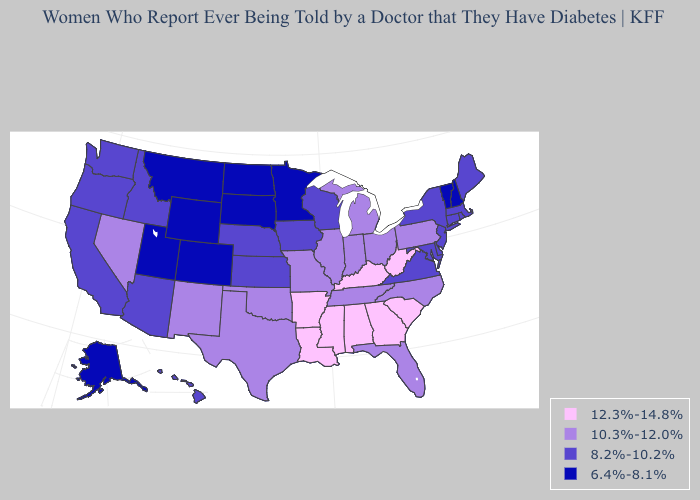What is the value of North Dakota?
Give a very brief answer. 6.4%-8.1%. Which states have the highest value in the USA?
Give a very brief answer. Alabama, Arkansas, Georgia, Kentucky, Louisiana, Mississippi, South Carolina, West Virginia. Which states have the lowest value in the South?
Short answer required. Delaware, Maryland, Virginia. Which states have the highest value in the USA?
Write a very short answer. Alabama, Arkansas, Georgia, Kentucky, Louisiana, Mississippi, South Carolina, West Virginia. What is the lowest value in states that border Maryland?
Keep it brief. 8.2%-10.2%. Name the states that have a value in the range 8.2%-10.2%?
Answer briefly. Arizona, California, Connecticut, Delaware, Hawaii, Idaho, Iowa, Kansas, Maine, Maryland, Massachusetts, Nebraska, New Jersey, New York, Oregon, Rhode Island, Virginia, Washington, Wisconsin. What is the lowest value in the USA?
Concise answer only. 6.4%-8.1%. Name the states that have a value in the range 10.3%-12.0%?
Keep it brief. Florida, Illinois, Indiana, Michigan, Missouri, Nevada, New Mexico, North Carolina, Ohio, Oklahoma, Pennsylvania, Tennessee, Texas. Among the states that border New Jersey , which have the highest value?
Quick response, please. Pennsylvania. What is the lowest value in the USA?
Give a very brief answer. 6.4%-8.1%. Does Pennsylvania have a higher value than Maine?
Give a very brief answer. Yes. Name the states that have a value in the range 8.2%-10.2%?
Quick response, please. Arizona, California, Connecticut, Delaware, Hawaii, Idaho, Iowa, Kansas, Maine, Maryland, Massachusetts, Nebraska, New Jersey, New York, Oregon, Rhode Island, Virginia, Washington, Wisconsin. Among the states that border Washington , which have the highest value?
Give a very brief answer. Idaho, Oregon. Does North Dakota have the lowest value in the MidWest?
Give a very brief answer. Yes. What is the value of Colorado?
Keep it brief. 6.4%-8.1%. 